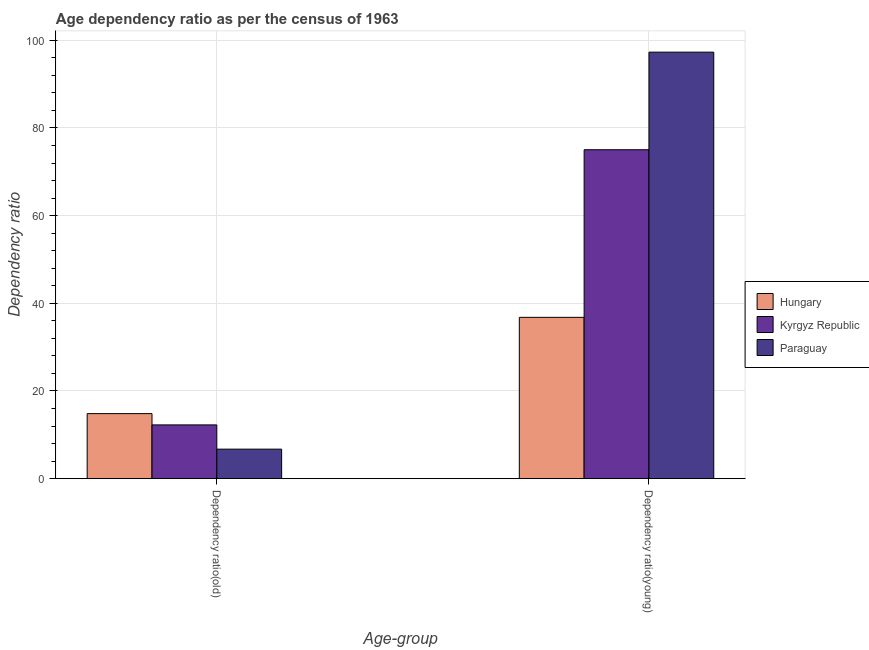How many different coloured bars are there?
Keep it short and to the point. 3. Are the number of bars per tick equal to the number of legend labels?
Make the answer very short. Yes. How many bars are there on the 1st tick from the left?
Provide a succinct answer. 3. What is the label of the 2nd group of bars from the left?
Make the answer very short. Dependency ratio(young). What is the age dependency ratio(old) in Hungary?
Ensure brevity in your answer.  14.83. Across all countries, what is the maximum age dependency ratio(old)?
Your response must be concise. 14.83. Across all countries, what is the minimum age dependency ratio(young)?
Provide a short and direct response. 36.79. In which country was the age dependency ratio(old) maximum?
Offer a terse response. Hungary. In which country was the age dependency ratio(old) minimum?
Give a very brief answer. Paraguay. What is the total age dependency ratio(young) in the graph?
Your answer should be very brief. 209.13. What is the difference between the age dependency ratio(young) in Kyrgyz Republic and that in Hungary?
Offer a very short reply. 38.24. What is the difference between the age dependency ratio(young) in Paraguay and the age dependency ratio(old) in Kyrgyz Republic?
Ensure brevity in your answer.  85.05. What is the average age dependency ratio(young) per country?
Keep it short and to the point. 69.71. What is the difference between the age dependency ratio(old) and age dependency ratio(young) in Hungary?
Make the answer very short. -21.97. In how many countries, is the age dependency ratio(young) greater than 64 ?
Offer a terse response. 2. What is the ratio of the age dependency ratio(old) in Kyrgyz Republic to that in Paraguay?
Ensure brevity in your answer.  1.82. In how many countries, is the age dependency ratio(old) greater than the average age dependency ratio(old) taken over all countries?
Offer a terse response. 2. What does the 3rd bar from the left in Dependency ratio(young) represents?
Give a very brief answer. Paraguay. What does the 1st bar from the right in Dependency ratio(young) represents?
Ensure brevity in your answer.  Paraguay. How many countries are there in the graph?
Ensure brevity in your answer.  3. Does the graph contain any zero values?
Your answer should be very brief. No. Where does the legend appear in the graph?
Offer a very short reply. Center right. How many legend labels are there?
Give a very brief answer. 3. How are the legend labels stacked?
Give a very brief answer. Vertical. What is the title of the graph?
Make the answer very short. Age dependency ratio as per the census of 1963. Does "Mauritius" appear as one of the legend labels in the graph?
Provide a succinct answer. No. What is the label or title of the X-axis?
Ensure brevity in your answer.  Age-group. What is the label or title of the Y-axis?
Ensure brevity in your answer.  Dependency ratio. What is the Dependency ratio in Hungary in Dependency ratio(old)?
Ensure brevity in your answer.  14.83. What is the Dependency ratio in Kyrgyz Republic in Dependency ratio(old)?
Your answer should be very brief. 12.25. What is the Dependency ratio in Paraguay in Dependency ratio(old)?
Offer a very short reply. 6.72. What is the Dependency ratio of Hungary in Dependency ratio(young)?
Make the answer very short. 36.79. What is the Dependency ratio in Kyrgyz Republic in Dependency ratio(young)?
Offer a terse response. 75.04. What is the Dependency ratio of Paraguay in Dependency ratio(young)?
Offer a very short reply. 97.3. Across all Age-group, what is the maximum Dependency ratio in Hungary?
Give a very brief answer. 36.79. Across all Age-group, what is the maximum Dependency ratio in Kyrgyz Republic?
Keep it short and to the point. 75.04. Across all Age-group, what is the maximum Dependency ratio of Paraguay?
Give a very brief answer. 97.3. Across all Age-group, what is the minimum Dependency ratio of Hungary?
Your answer should be compact. 14.83. Across all Age-group, what is the minimum Dependency ratio of Kyrgyz Republic?
Your answer should be compact. 12.25. Across all Age-group, what is the minimum Dependency ratio in Paraguay?
Offer a terse response. 6.72. What is the total Dependency ratio of Hungary in the graph?
Make the answer very short. 51.62. What is the total Dependency ratio in Kyrgyz Republic in the graph?
Your answer should be compact. 87.29. What is the total Dependency ratio of Paraguay in the graph?
Provide a short and direct response. 104.02. What is the difference between the Dependency ratio of Hungary in Dependency ratio(old) and that in Dependency ratio(young)?
Keep it short and to the point. -21.97. What is the difference between the Dependency ratio in Kyrgyz Republic in Dependency ratio(old) and that in Dependency ratio(young)?
Give a very brief answer. -62.78. What is the difference between the Dependency ratio of Paraguay in Dependency ratio(old) and that in Dependency ratio(young)?
Keep it short and to the point. -90.58. What is the difference between the Dependency ratio in Hungary in Dependency ratio(old) and the Dependency ratio in Kyrgyz Republic in Dependency ratio(young)?
Keep it short and to the point. -60.21. What is the difference between the Dependency ratio in Hungary in Dependency ratio(old) and the Dependency ratio in Paraguay in Dependency ratio(young)?
Your answer should be compact. -82.47. What is the difference between the Dependency ratio in Kyrgyz Republic in Dependency ratio(old) and the Dependency ratio in Paraguay in Dependency ratio(young)?
Your response must be concise. -85.05. What is the average Dependency ratio of Hungary per Age-group?
Keep it short and to the point. 25.81. What is the average Dependency ratio of Kyrgyz Republic per Age-group?
Give a very brief answer. 43.65. What is the average Dependency ratio in Paraguay per Age-group?
Offer a terse response. 52.01. What is the difference between the Dependency ratio of Hungary and Dependency ratio of Kyrgyz Republic in Dependency ratio(old)?
Give a very brief answer. 2.57. What is the difference between the Dependency ratio of Hungary and Dependency ratio of Paraguay in Dependency ratio(old)?
Keep it short and to the point. 8.11. What is the difference between the Dependency ratio of Kyrgyz Republic and Dependency ratio of Paraguay in Dependency ratio(old)?
Offer a terse response. 5.53. What is the difference between the Dependency ratio of Hungary and Dependency ratio of Kyrgyz Republic in Dependency ratio(young)?
Offer a terse response. -38.24. What is the difference between the Dependency ratio of Hungary and Dependency ratio of Paraguay in Dependency ratio(young)?
Provide a short and direct response. -60.51. What is the difference between the Dependency ratio in Kyrgyz Republic and Dependency ratio in Paraguay in Dependency ratio(young)?
Your response must be concise. -22.26. What is the ratio of the Dependency ratio in Hungary in Dependency ratio(old) to that in Dependency ratio(young)?
Make the answer very short. 0.4. What is the ratio of the Dependency ratio of Kyrgyz Republic in Dependency ratio(old) to that in Dependency ratio(young)?
Ensure brevity in your answer.  0.16. What is the ratio of the Dependency ratio in Paraguay in Dependency ratio(old) to that in Dependency ratio(young)?
Make the answer very short. 0.07. What is the difference between the highest and the second highest Dependency ratio of Hungary?
Keep it short and to the point. 21.97. What is the difference between the highest and the second highest Dependency ratio in Kyrgyz Republic?
Keep it short and to the point. 62.78. What is the difference between the highest and the second highest Dependency ratio in Paraguay?
Provide a short and direct response. 90.58. What is the difference between the highest and the lowest Dependency ratio of Hungary?
Provide a short and direct response. 21.97. What is the difference between the highest and the lowest Dependency ratio in Kyrgyz Republic?
Your answer should be very brief. 62.78. What is the difference between the highest and the lowest Dependency ratio of Paraguay?
Make the answer very short. 90.58. 